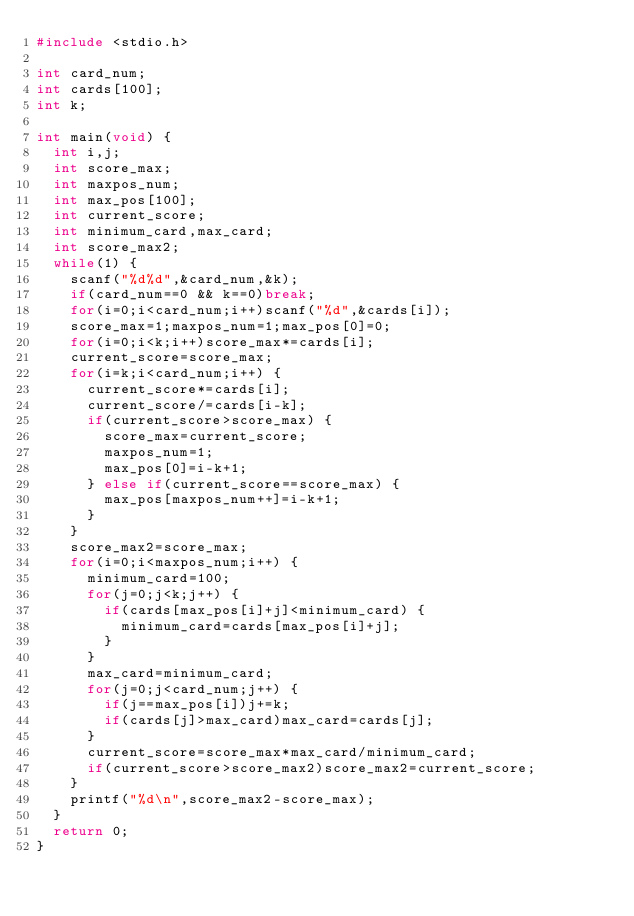<code> <loc_0><loc_0><loc_500><loc_500><_C_>#include <stdio.h>

int card_num;
int cards[100];
int k;

int main(void) {
	int i,j;
	int score_max;
	int maxpos_num;
	int max_pos[100];
	int current_score;
	int minimum_card,max_card;
	int score_max2;
	while(1) {
		scanf("%d%d",&card_num,&k);
		if(card_num==0 && k==0)break;
		for(i=0;i<card_num;i++)scanf("%d",&cards[i]);
		score_max=1;maxpos_num=1;max_pos[0]=0;
		for(i=0;i<k;i++)score_max*=cards[i];
		current_score=score_max;
		for(i=k;i<card_num;i++) {
			current_score*=cards[i];
			current_score/=cards[i-k];
			if(current_score>score_max) {
				score_max=current_score;
				maxpos_num=1;
				max_pos[0]=i-k+1;
			} else if(current_score==score_max) {
				max_pos[maxpos_num++]=i-k+1;
			}
		}
		score_max2=score_max;
		for(i=0;i<maxpos_num;i++) {
			minimum_card=100;
			for(j=0;j<k;j++) {
				if(cards[max_pos[i]+j]<minimum_card) {
					minimum_card=cards[max_pos[i]+j];
				}
			}
			max_card=minimum_card;
			for(j=0;j<card_num;j++) {
				if(j==max_pos[i])j+=k;
				if(cards[j]>max_card)max_card=cards[j];
			}
			current_score=score_max*max_card/minimum_card;
			if(current_score>score_max2)score_max2=current_score;
		}
		printf("%d\n",score_max2-score_max);
	}
	return 0;
}</code> 